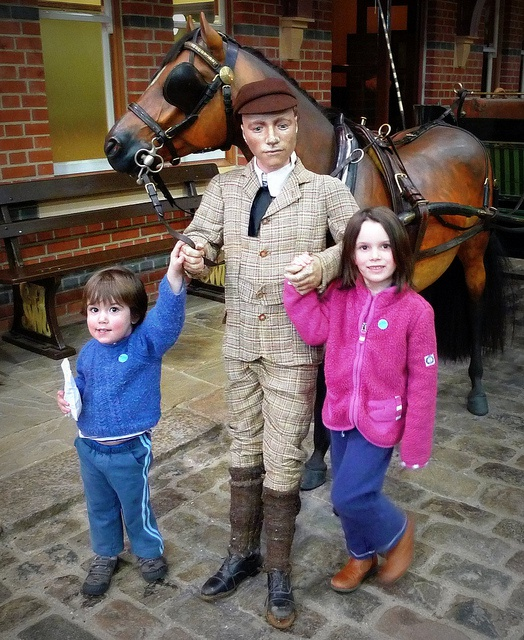Describe the objects in this image and their specific colors. I can see people in black, lightgray, darkgray, and gray tones, horse in black, gray, and maroon tones, people in black, magenta, navy, and blue tones, people in black, blue, gray, and navy tones, and bench in black, maroon, olive, and gray tones in this image. 